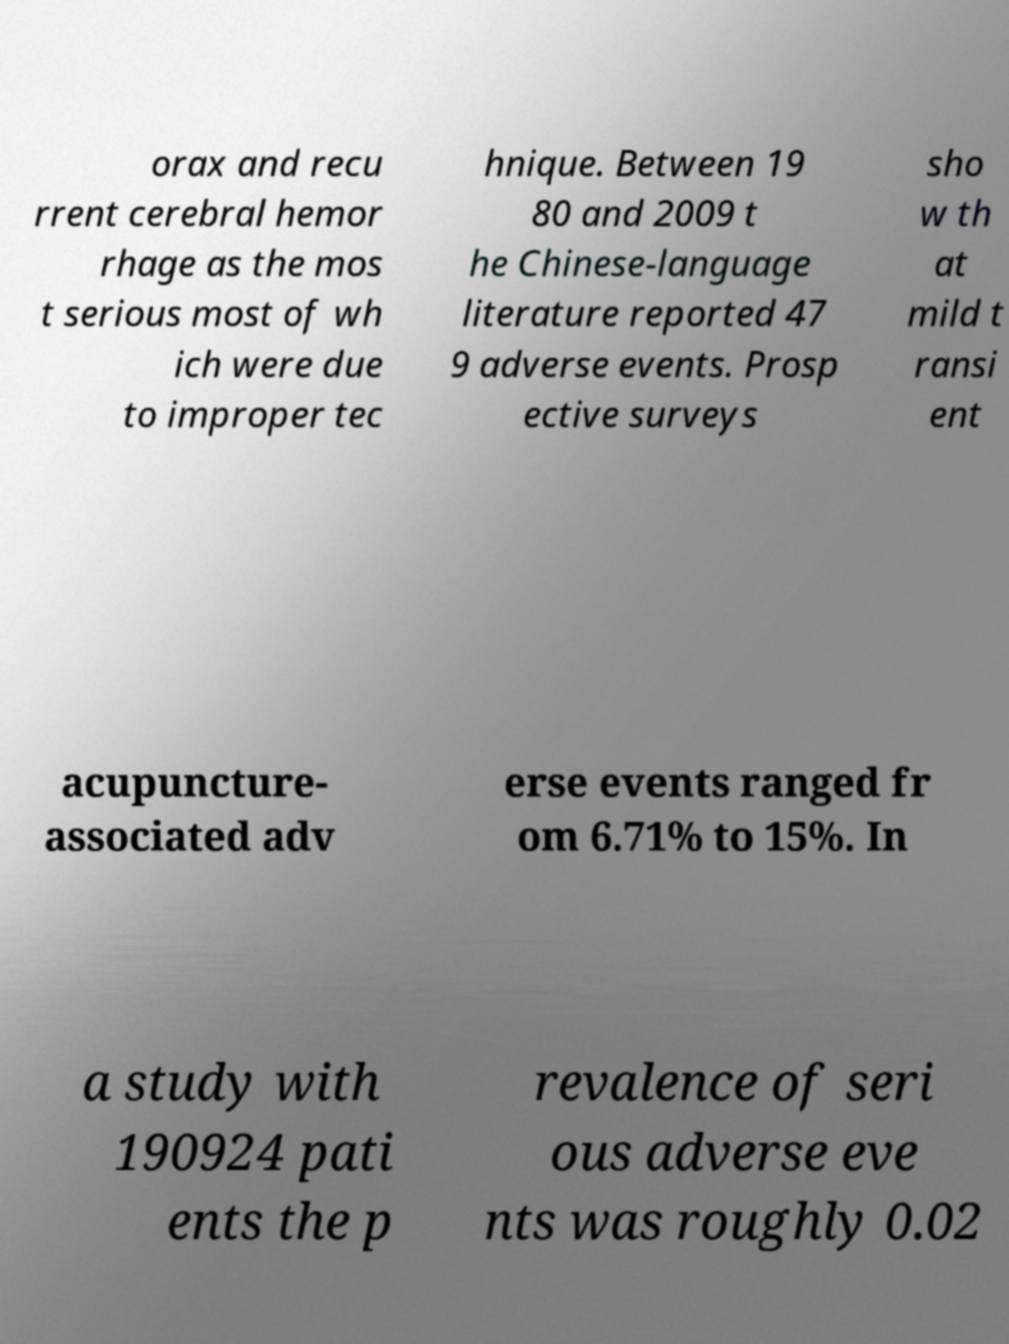I need the written content from this picture converted into text. Can you do that? orax and recu rrent cerebral hemor rhage as the mos t serious most of wh ich were due to improper tec hnique. Between 19 80 and 2009 t he Chinese-language literature reported 47 9 adverse events. Prosp ective surveys sho w th at mild t ransi ent acupuncture- associated adv erse events ranged fr om 6.71% to 15%. In a study with 190924 pati ents the p revalence of seri ous adverse eve nts was roughly 0.02 